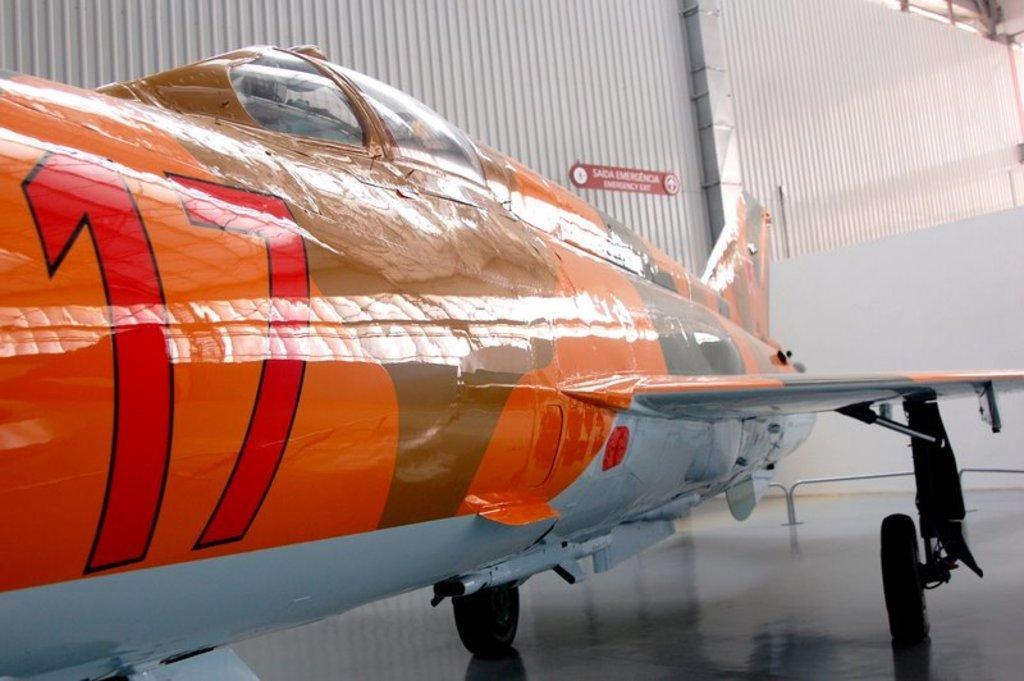How would you summarize this image in a sentence or two? In this image in the front there is an airplane. In the background there is an object which is white in colour and there is a metal sheet and there is some text written on the metal sheet. 